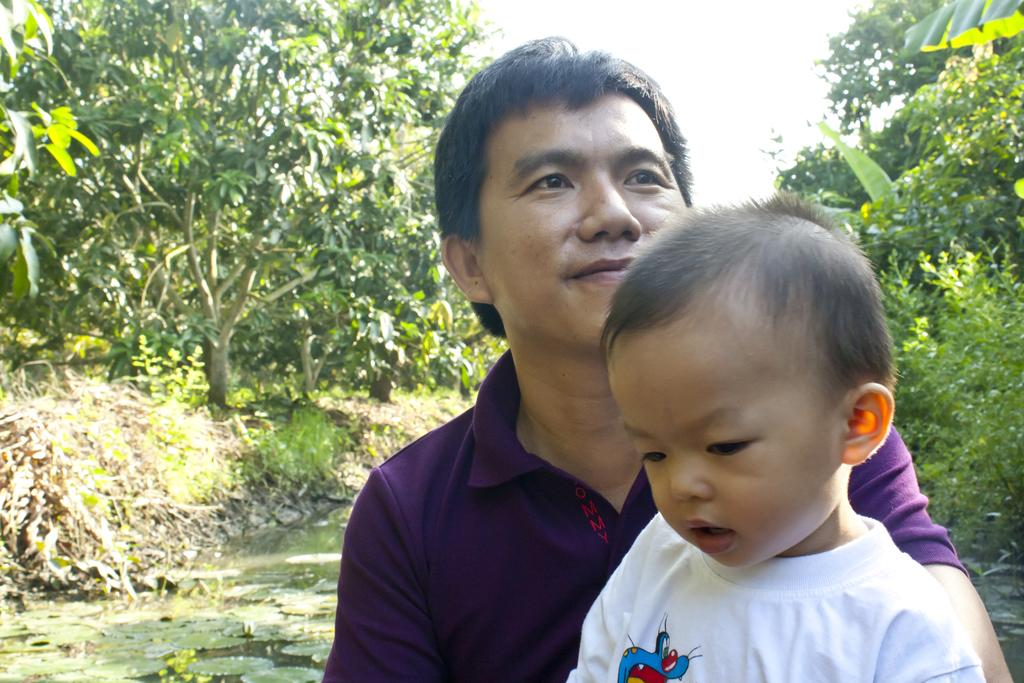Who is present in the image? There is a man and a kid in the image. What is happening with the leaves in the image? The leaves are on the water in the image. What type of vegetation can be seen in the image? There are plants and trees in the image. What can be seen in the background of the image? The sky is visible in the background of the image. What type of pan is being used to cook the leaves in the image? There is no pan or cooking activity present in the image; the leaves are simply on the water. 